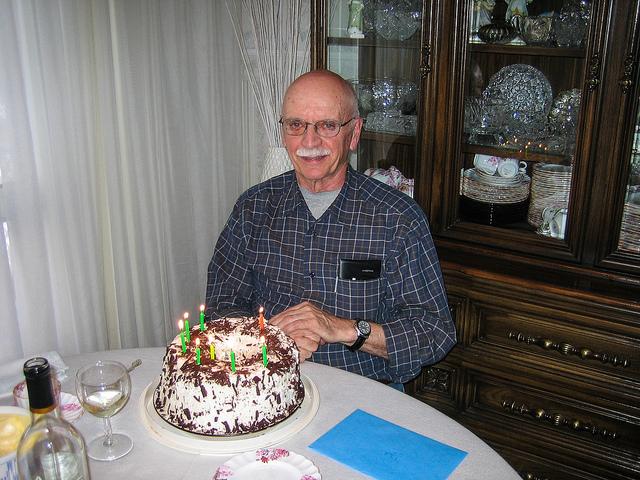Does he have a beard?
Keep it brief. No. What occasion is being celebrated in this photo?
Quick response, please. Birthday. How many candles are on the cake?
Answer briefly. 8. 